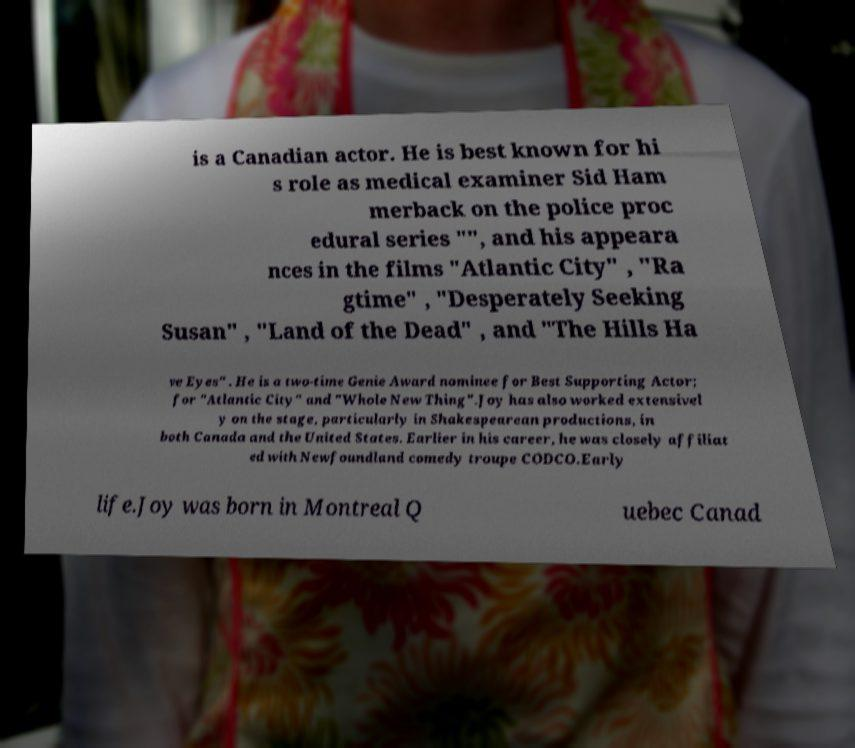Please read and relay the text visible in this image. What does it say? is a Canadian actor. He is best known for hi s role as medical examiner Sid Ham merback on the police proc edural series "", and his appeara nces in the films "Atlantic City" , "Ra gtime" , "Desperately Seeking Susan" , "Land of the Dead" , and "The Hills Ha ve Eyes" . He is a two-time Genie Award nominee for Best Supporting Actor; for "Atlantic City" and "Whole New Thing".Joy has also worked extensivel y on the stage, particularly in Shakespearean productions, in both Canada and the United States. Earlier in his career, he was closely affiliat ed with Newfoundland comedy troupe CODCO.Early life.Joy was born in Montreal Q uebec Canad 